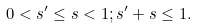<formula> <loc_0><loc_0><loc_500><loc_500>0 < s ^ { \prime } \leq s < 1 ; s ^ { \prime } + s \leq 1 .</formula> 